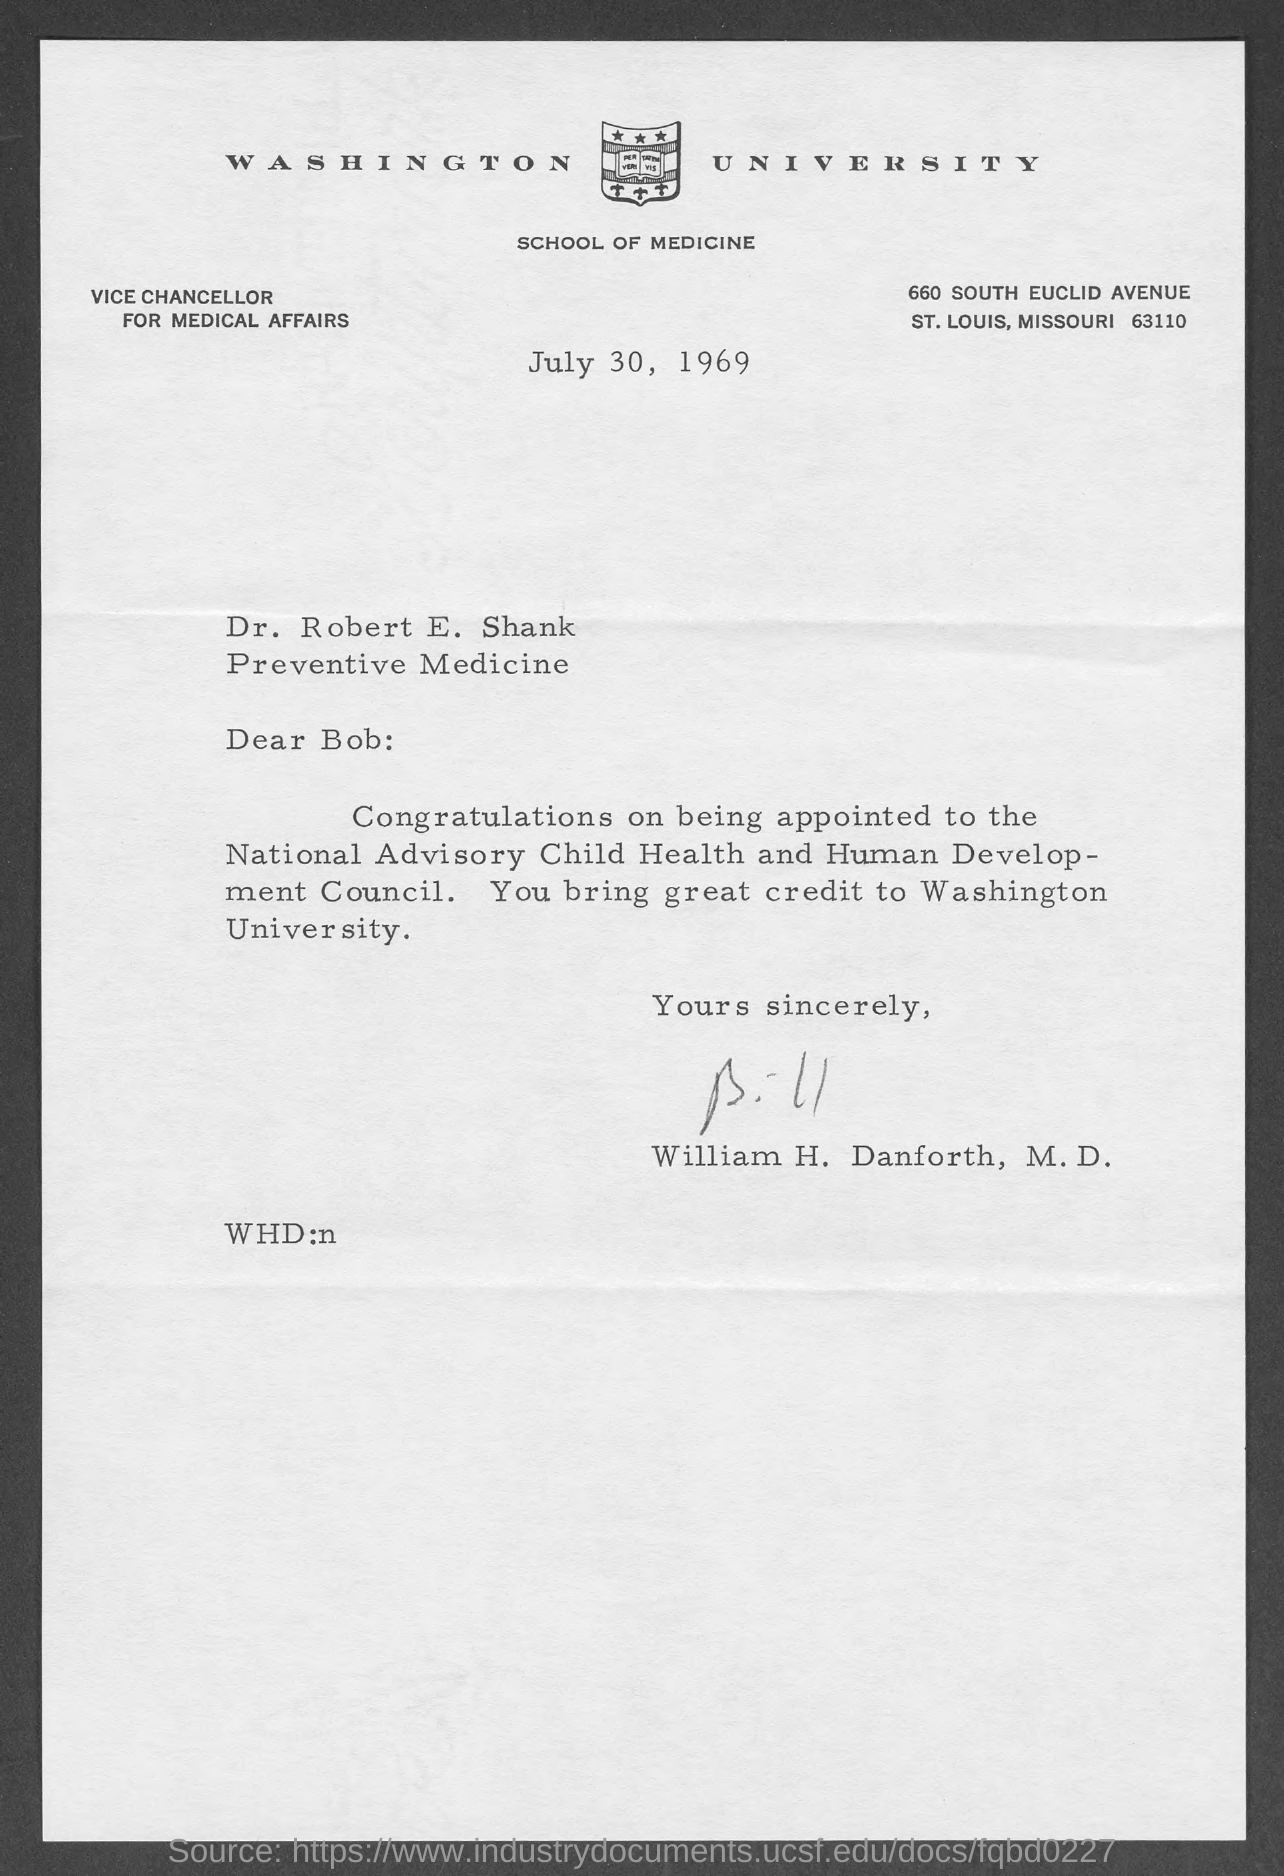What is the date mentioned ?
Offer a very short reply. JULY 30, 1969. What is the name of the university
Make the answer very short. Washington University. This letter is written by whom
Provide a succinct answer. William H. Danforth. 